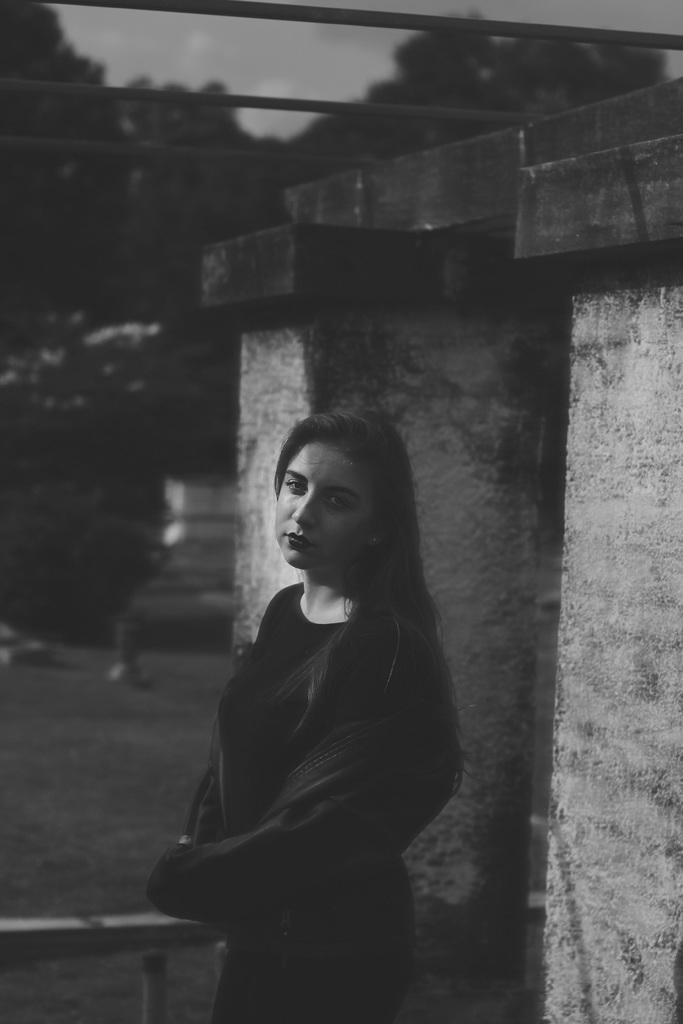What is the main subject of the image? There is a woman standing in the image. What can be seen in the background of the image? There are trees and the sky visible in the background of the image. How many pies are on the table in the image? There is no table or pies present in the image; it features a woman standing with trees and the sky in the background. 